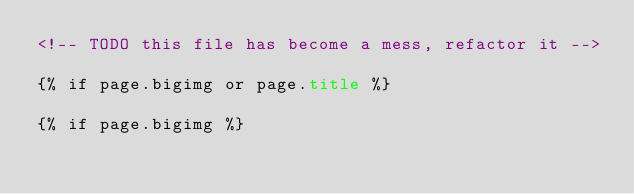<code> <loc_0><loc_0><loc_500><loc_500><_HTML_><!-- TODO this file has become a mess, refactor it -->

{% if page.bigimg or page.title %}

{% if page.bigimg %}</code> 